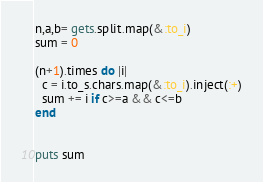<code> <loc_0><loc_0><loc_500><loc_500><_Ruby_>n,a,b= gets.split.map(&:to_i)
sum = 0

(n+1).times do |i|
  c = i.to_s.chars.map(&:to_i).inject(:+)
  sum += i if c>=a && c<=b
end
  

puts sum</code> 